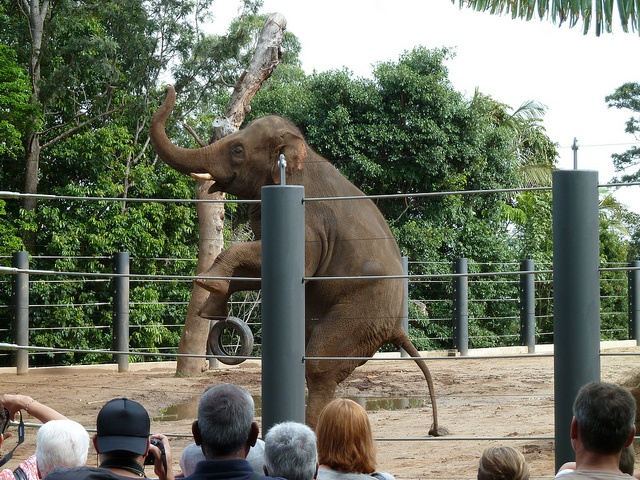Describe the objects in this image and their specific colors. I can see elephant in black, gray, and maroon tones, people in black, gray, darkgray, and maroon tones, people in black, gray, and darkgray tones, people in black, gray, and blue tones, and people in black, maroon, and gray tones in this image. 